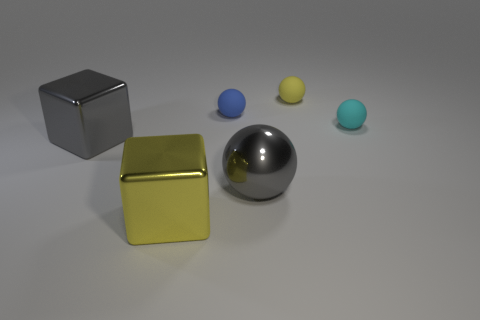Add 1 small yellow objects. How many objects exist? 7 Subtract all red balls. Subtract all yellow cubes. How many balls are left? 4 Subtract all cubes. How many objects are left? 4 Add 3 cyan rubber balls. How many cyan rubber balls exist? 4 Subtract 0 gray cylinders. How many objects are left? 6 Subtract all yellow rubber things. Subtract all matte balls. How many objects are left? 2 Add 6 tiny matte things. How many tiny matte things are left? 9 